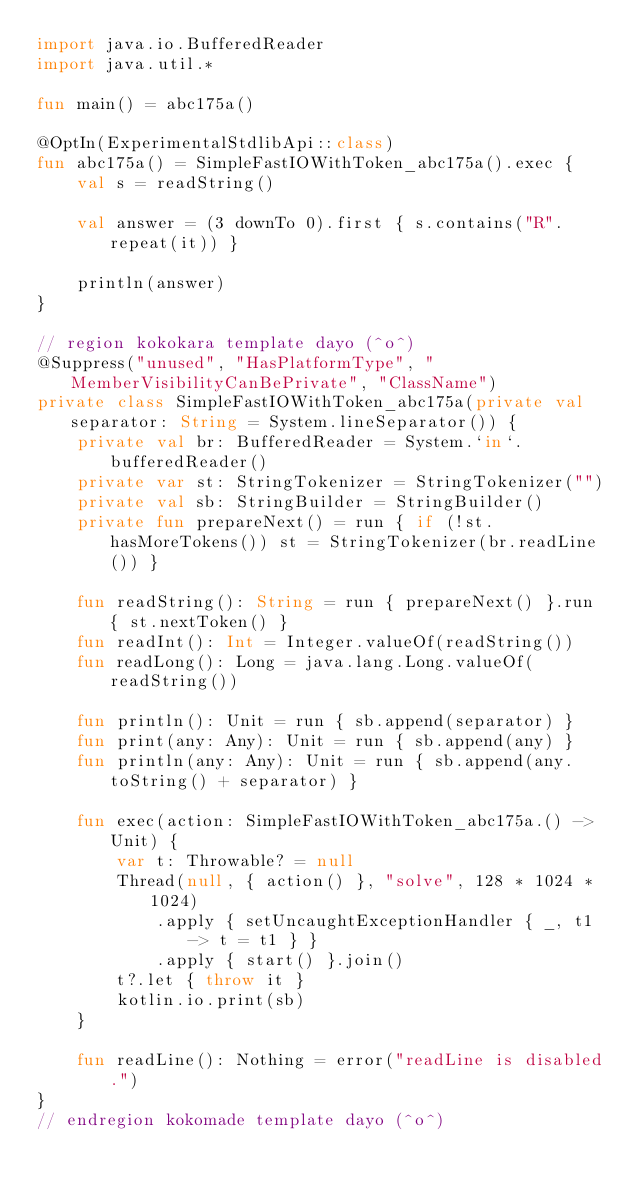<code> <loc_0><loc_0><loc_500><loc_500><_Kotlin_>import java.io.BufferedReader
import java.util.*

fun main() = abc175a()

@OptIn(ExperimentalStdlibApi::class)
fun abc175a() = SimpleFastIOWithToken_abc175a().exec {
    val s = readString()

    val answer = (3 downTo 0).first { s.contains("R".repeat(it)) }

    println(answer)
}

// region kokokara template dayo (^o^)
@Suppress("unused", "HasPlatformType", "MemberVisibilityCanBePrivate", "ClassName")
private class SimpleFastIOWithToken_abc175a(private val separator: String = System.lineSeparator()) {
    private val br: BufferedReader = System.`in`.bufferedReader()
    private var st: StringTokenizer = StringTokenizer("")
    private val sb: StringBuilder = StringBuilder()
    private fun prepareNext() = run { if (!st.hasMoreTokens()) st = StringTokenizer(br.readLine()) }

    fun readString(): String = run { prepareNext() }.run { st.nextToken() }
    fun readInt(): Int = Integer.valueOf(readString())
    fun readLong(): Long = java.lang.Long.valueOf(readString())

    fun println(): Unit = run { sb.append(separator) }
    fun print(any: Any): Unit = run { sb.append(any) }
    fun println(any: Any): Unit = run { sb.append(any.toString() + separator) }

    fun exec(action: SimpleFastIOWithToken_abc175a.() -> Unit) {
        var t: Throwable? = null
        Thread(null, { action() }, "solve", 128 * 1024 * 1024)
            .apply { setUncaughtExceptionHandler { _, t1 -> t = t1 } }
            .apply { start() }.join()
        t?.let { throw it }
        kotlin.io.print(sb)
    }

    fun readLine(): Nothing = error("readLine is disabled.")
}
// endregion kokomade template dayo (^o^)
</code> 